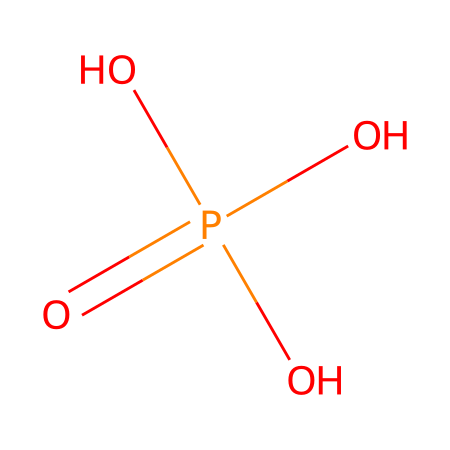What is the name of this chemical? This chemical structure corresponds to the SMILES representation provided, which is known as phosphoric acid. It is characterized by the presence of one phosphorus atom bonded to four oxygen atoms, one of which is double-bonded (indicating it is an acid).
Answer: phosphoric acid How many oxygen atoms are present in phosphoric acid? By examining the SMILES representation, we can see that there are four oxygen atoms (indicated by four 'O's). This is a straightforward count of all the oxygen symbols in the structure.
Answer: four What is the oxidation state of phosphorus in this compound? The phosphorus atom in phosphoric acid has five bonds (one double bond with an oxygen and three single bonds), which results in its oxidation state being +5. To find this, consider the typical states of oxygen (-2) and factor in phosphorus's typical valency.
Answer: +5 What role does phosphoric acid play in cuisine? Phosphoric acid acts as a food additive that can be used for acidity regulation and serves as a preservative. Understanding its functional role in food helps identify its significance in culinary applications.
Answer: acidity regulator Which type of bond connects phosphorus and oxygen in phosphoric acid? The structure shows that the phosphorus atom is connected to one oxygen through a double bond and three through single bonds. This variety dictates the nature of the chemical interactions.
Answer: double and single bonds Overall, how many hydrogen atoms are involved in phosphoric acid? Based on the structure, phosphoric acid contains three hydrogen atoms, as these are the number of hydroxyl (-OH) groups indicated. Each -OH contributes one hydrogen to the total.
Answer: three 